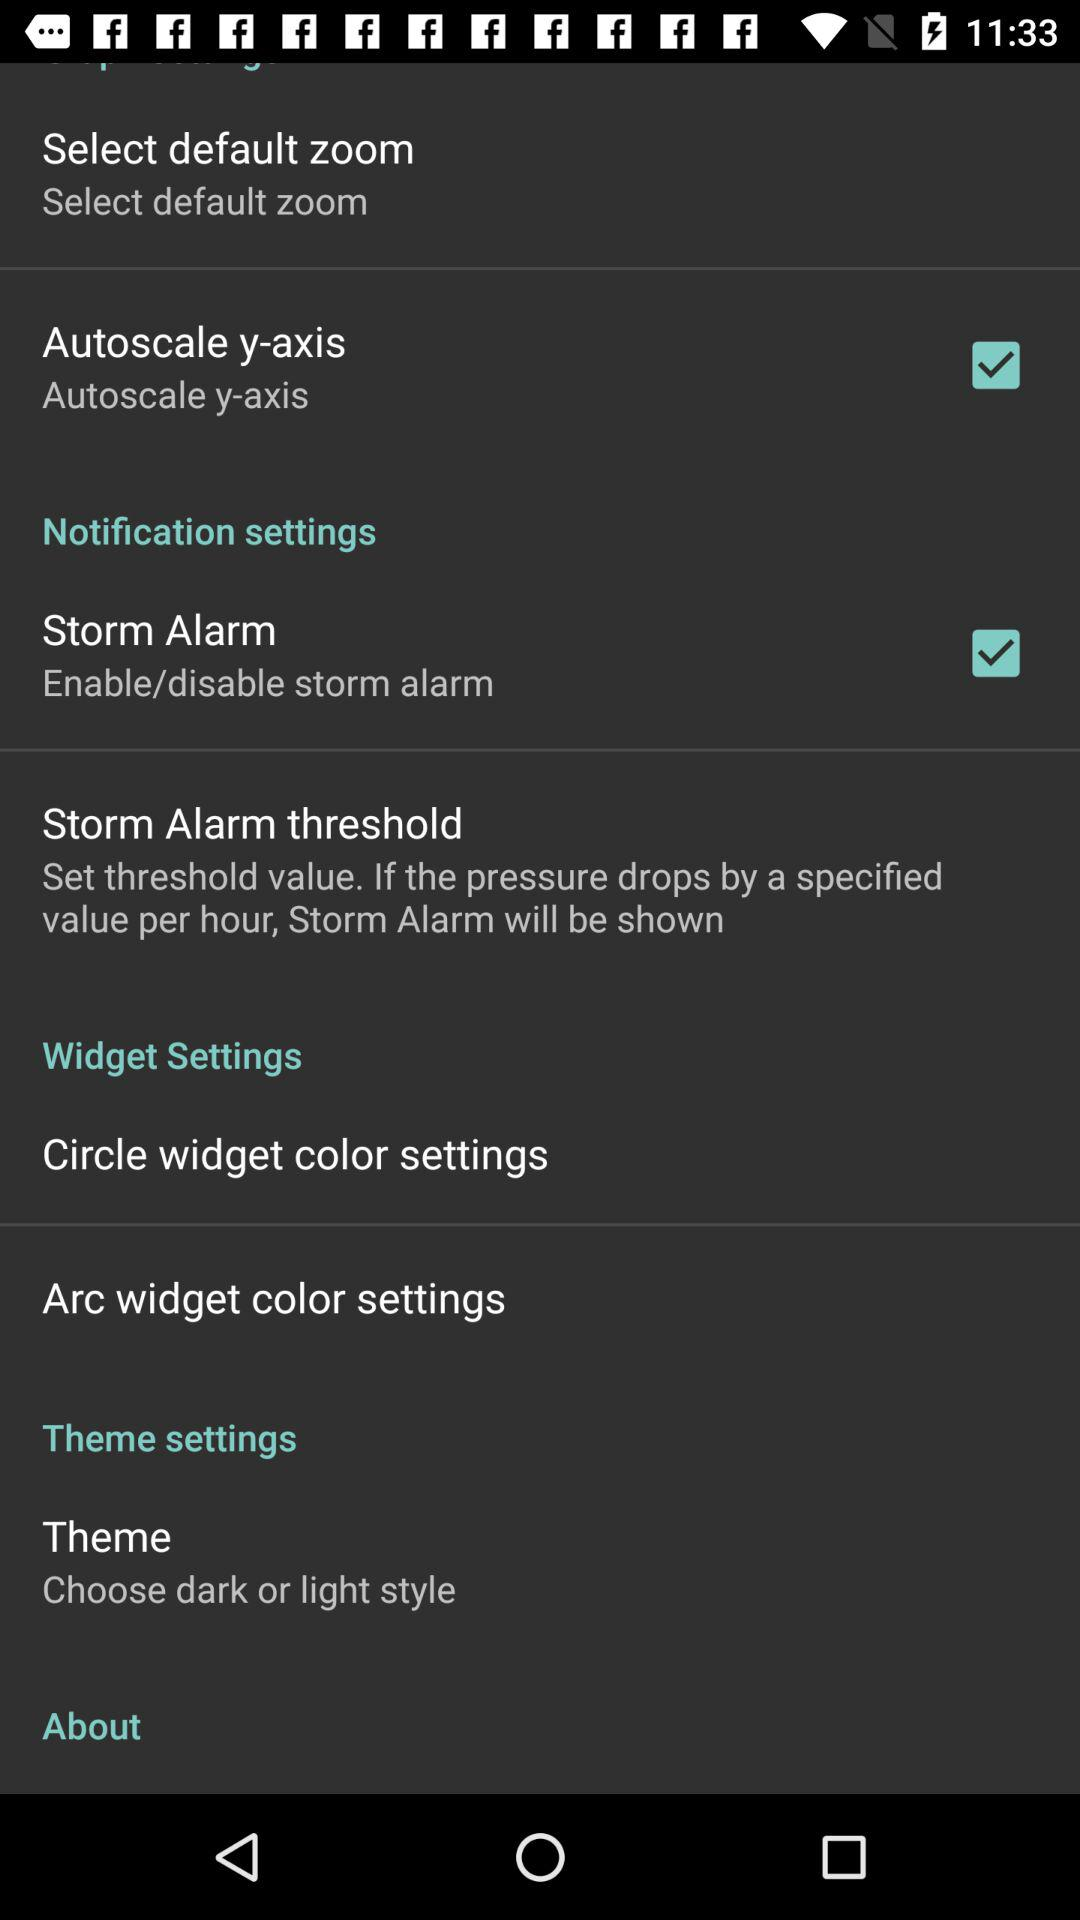How many of the settings have a checkbox?
Answer the question using a single word or phrase. 2 